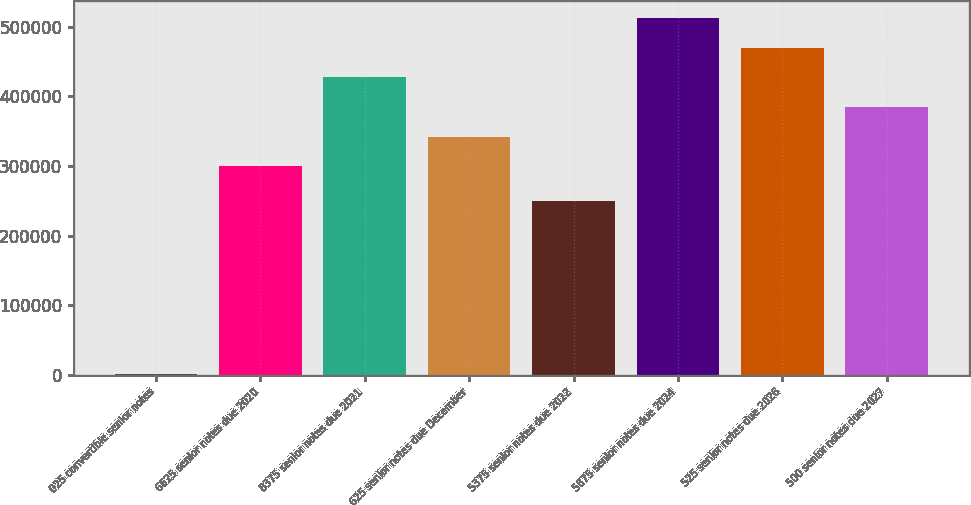<chart> <loc_0><loc_0><loc_500><loc_500><bar_chart><fcel>025 convertible senior notes<fcel>6625 senior notes due 2020<fcel>8375 senior notes due 2021<fcel>625 senior notes due December<fcel>5375 senior notes due 2022<fcel>5875 senior notes due 2024<fcel>525 senior notes due 2026<fcel>500 senior notes due 2027<nl><fcel>1300<fcel>300000<fcel>427110<fcel>342370<fcel>250000<fcel>511850<fcel>469480<fcel>384740<nl></chart> 